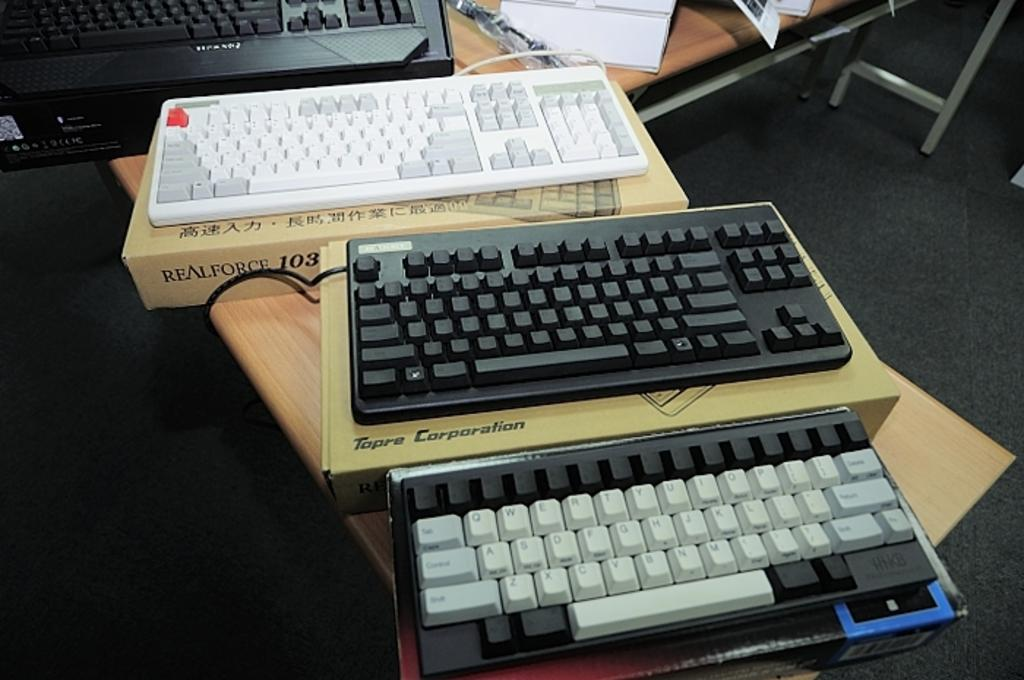<image>
Provide a brief description of the given image. A white and gray keyboard sits on top of a realforce box. 